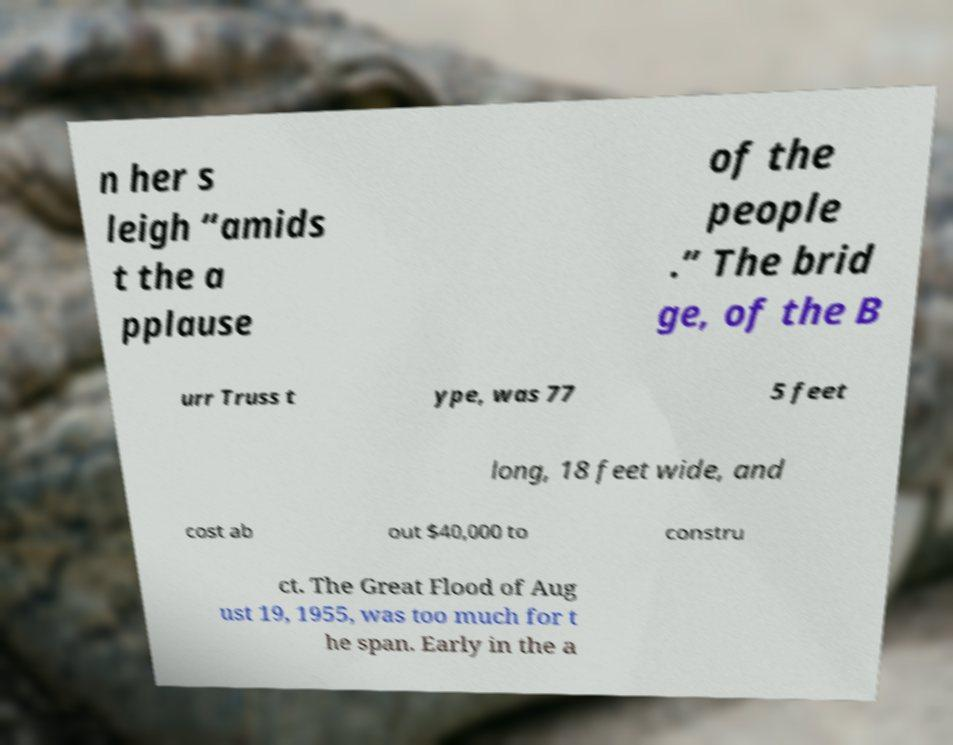Could you extract and type out the text from this image? n her s leigh “amids t the a pplause of the people .” The brid ge, of the B urr Truss t ype, was 77 5 feet long, 18 feet wide, and cost ab out $40,000 to constru ct. The Great Flood of Aug ust 19, 1955, was too much for t he span. Early in the a 